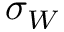Convert formula to latex. <formula><loc_0><loc_0><loc_500><loc_500>\sigma _ { W }</formula> 